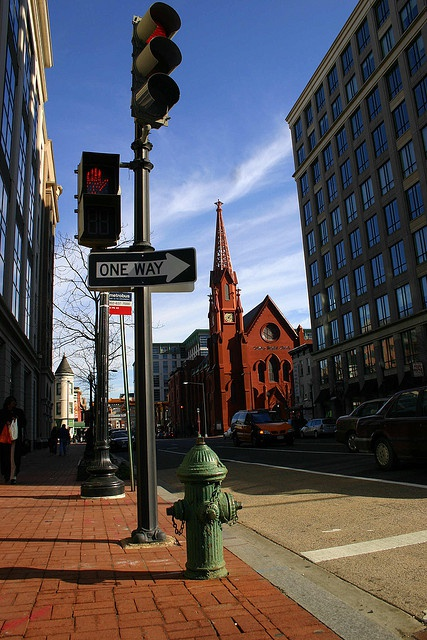Describe the objects in this image and their specific colors. I can see traffic light in black, gray, olive, and maroon tones, fire hydrant in black, olive, and darkgreen tones, traffic light in black, maroon, darkgray, and gray tones, car in black, gray, and darkgreen tones, and car in black, maroon, gray, and darkblue tones in this image. 